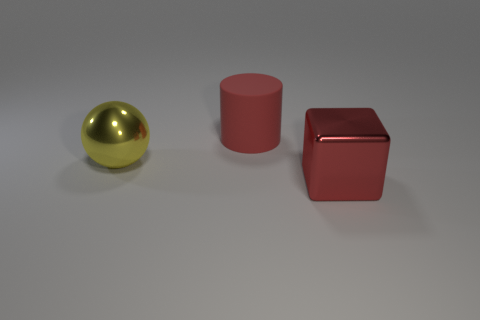Subtract all brown cubes. Subtract all red cylinders. How many cubes are left? 1 Add 3 yellow matte balls. How many objects exist? 6 Subtract all cylinders. How many objects are left? 2 Add 1 yellow metallic things. How many yellow metallic things are left? 2 Add 2 tiny matte cubes. How many tiny matte cubes exist? 2 Subtract 0 blue spheres. How many objects are left? 3 Subtract all large metallic balls. Subtract all big red matte things. How many objects are left? 1 